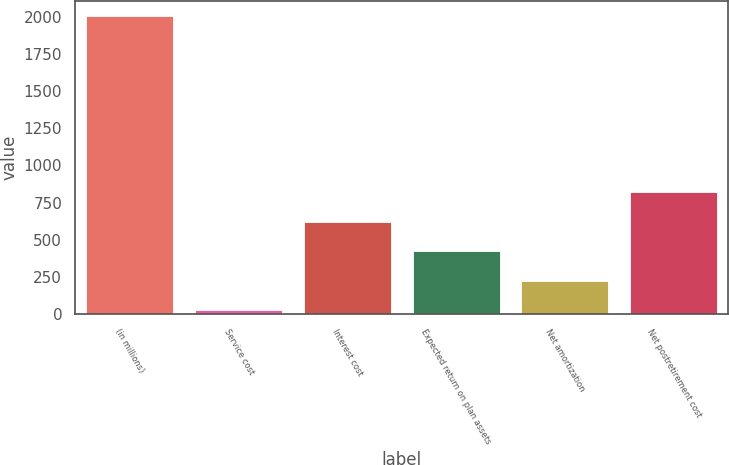Convert chart. <chart><loc_0><loc_0><loc_500><loc_500><bar_chart><fcel>(in millions)<fcel>Service cost<fcel>Interest cost<fcel>Expected return on plan assets<fcel>Net amortization<fcel>Net postretirement cost<nl><fcel>2007<fcel>27<fcel>621<fcel>423<fcel>225<fcel>819<nl></chart> 